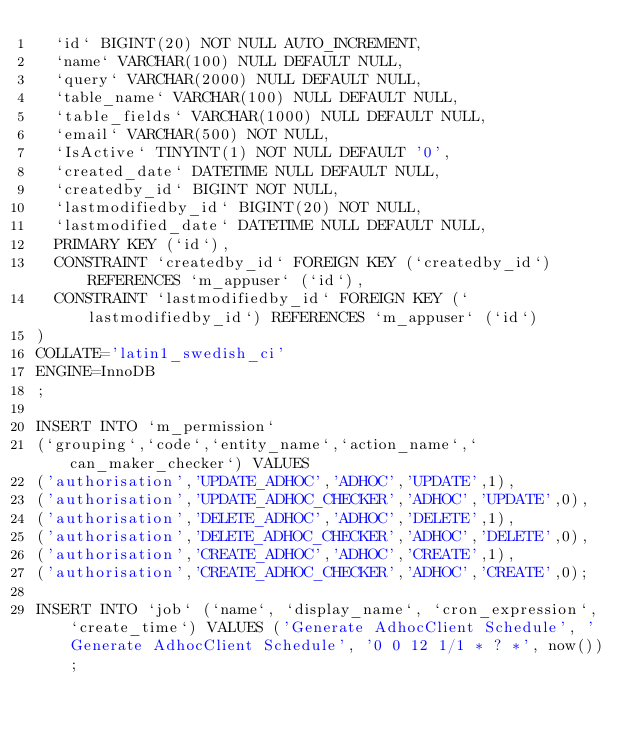Convert code to text. <code><loc_0><loc_0><loc_500><loc_500><_SQL_>	`id` BIGINT(20) NOT NULL AUTO_INCREMENT,
	`name` VARCHAR(100) NULL DEFAULT NULL,
	`query` VARCHAR(2000) NULL DEFAULT NULL,
	`table_name` VARCHAR(100) NULL DEFAULT NULL,
	`table_fields` VARCHAR(1000) NULL DEFAULT NULL,
	`email` VARCHAR(500) NOT NULL,
	`IsActive` TINYINT(1) NOT NULL DEFAULT '0',
	`created_date` DATETIME NULL DEFAULT NULL,
	`createdby_id` BIGINT NOT NULL,
	`lastmodifiedby_id` BIGINT(20) NOT NULL,
	`lastmodified_date` DATETIME NULL DEFAULT NULL,
	PRIMARY KEY (`id`),
	CONSTRAINT `createdby_id` FOREIGN KEY (`createdby_id`) REFERENCES `m_appuser` (`id`),
	CONSTRAINT `lastmodifiedby_id` FOREIGN KEY (`lastmodifiedby_id`) REFERENCES `m_appuser` (`id`)
)
COLLATE='latin1_swedish_ci'
ENGINE=InnoDB
;

INSERT INTO `m_permission`
(`grouping`,`code`,`entity_name`,`action_name`,`can_maker_checker`) VALUES
('authorisation','UPDATE_ADHOC','ADHOC','UPDATE',1),
('authorisation','UPDATE_ADHOC_CHECKER','ADHOC','UPDATE',0),
('authorisation','DELETE_ADHOC','ADHOC','DELETE',1),
('authorisation','DELETE_ADHOC_CHECKER','ADHOC','DELETE',0),
('authorisation','CREATE_ADHOC','ADHOC','CREATE',1),
('authorisation','CREATE_ADHOC_CHECKER','ADHOC','CREATE',0);

INSERT INTO `job` (`name`, `display_name`, `cron_expression`, `create_time`) VALUES ('Generate AdhocClient Schedule', 'Generate AdhocClient Schedule', '0 0 12 1/1 * ? *', now());
</code> 